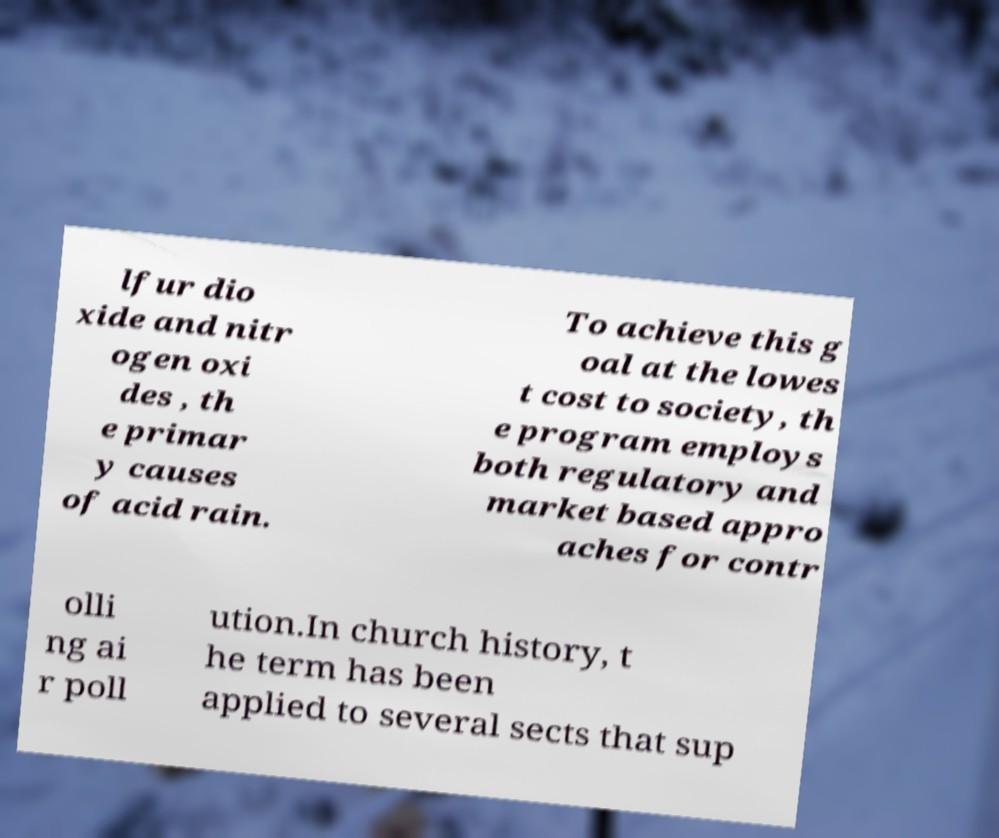There's text embedded in this image that I need extracted. Can you transcribe it verbatim? lfur dio xide and nitr ogen oxi des , th e primar y causes of acid rain. To achieve this g oal at the lowes t cost to society, th e program employs both regulatory and market based appro aches for contr olli ng ai r poll ution.In church history, t he term has been applied to several sects that sup 